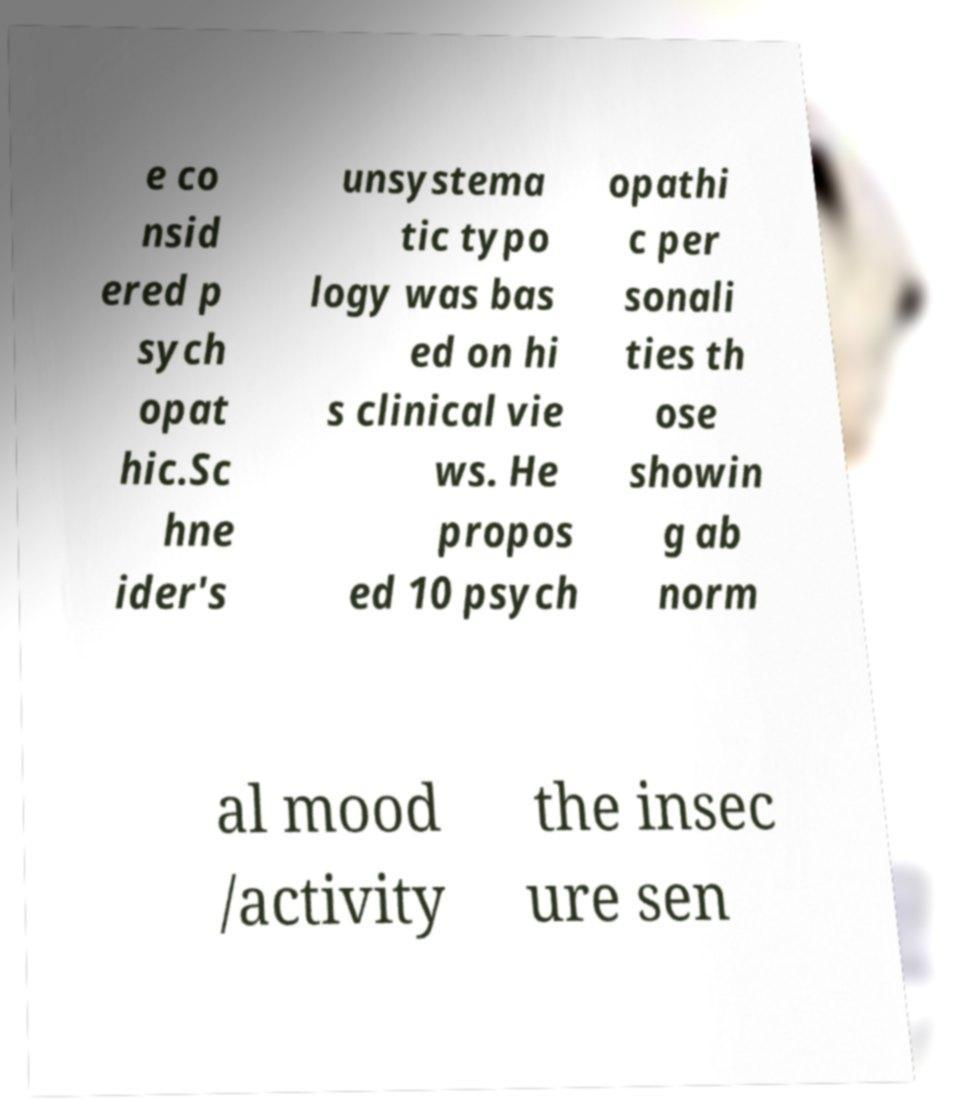Could you assist in decoding the text presented in this image and type it out clearly? e co nsid ered p sych opat hic.Sc hne ider's unsystema tic typo logy was bas ed on hi s clinical vie ws. He propos ed 10 psych opathi c per sonali ties th ose showin g ab norm al mood /activity the insec ure sen 